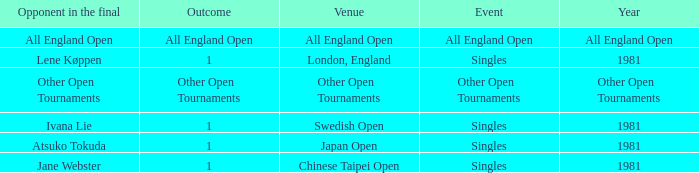What is the Outcome when All England Open is the Opponent in the final? All England Open. 